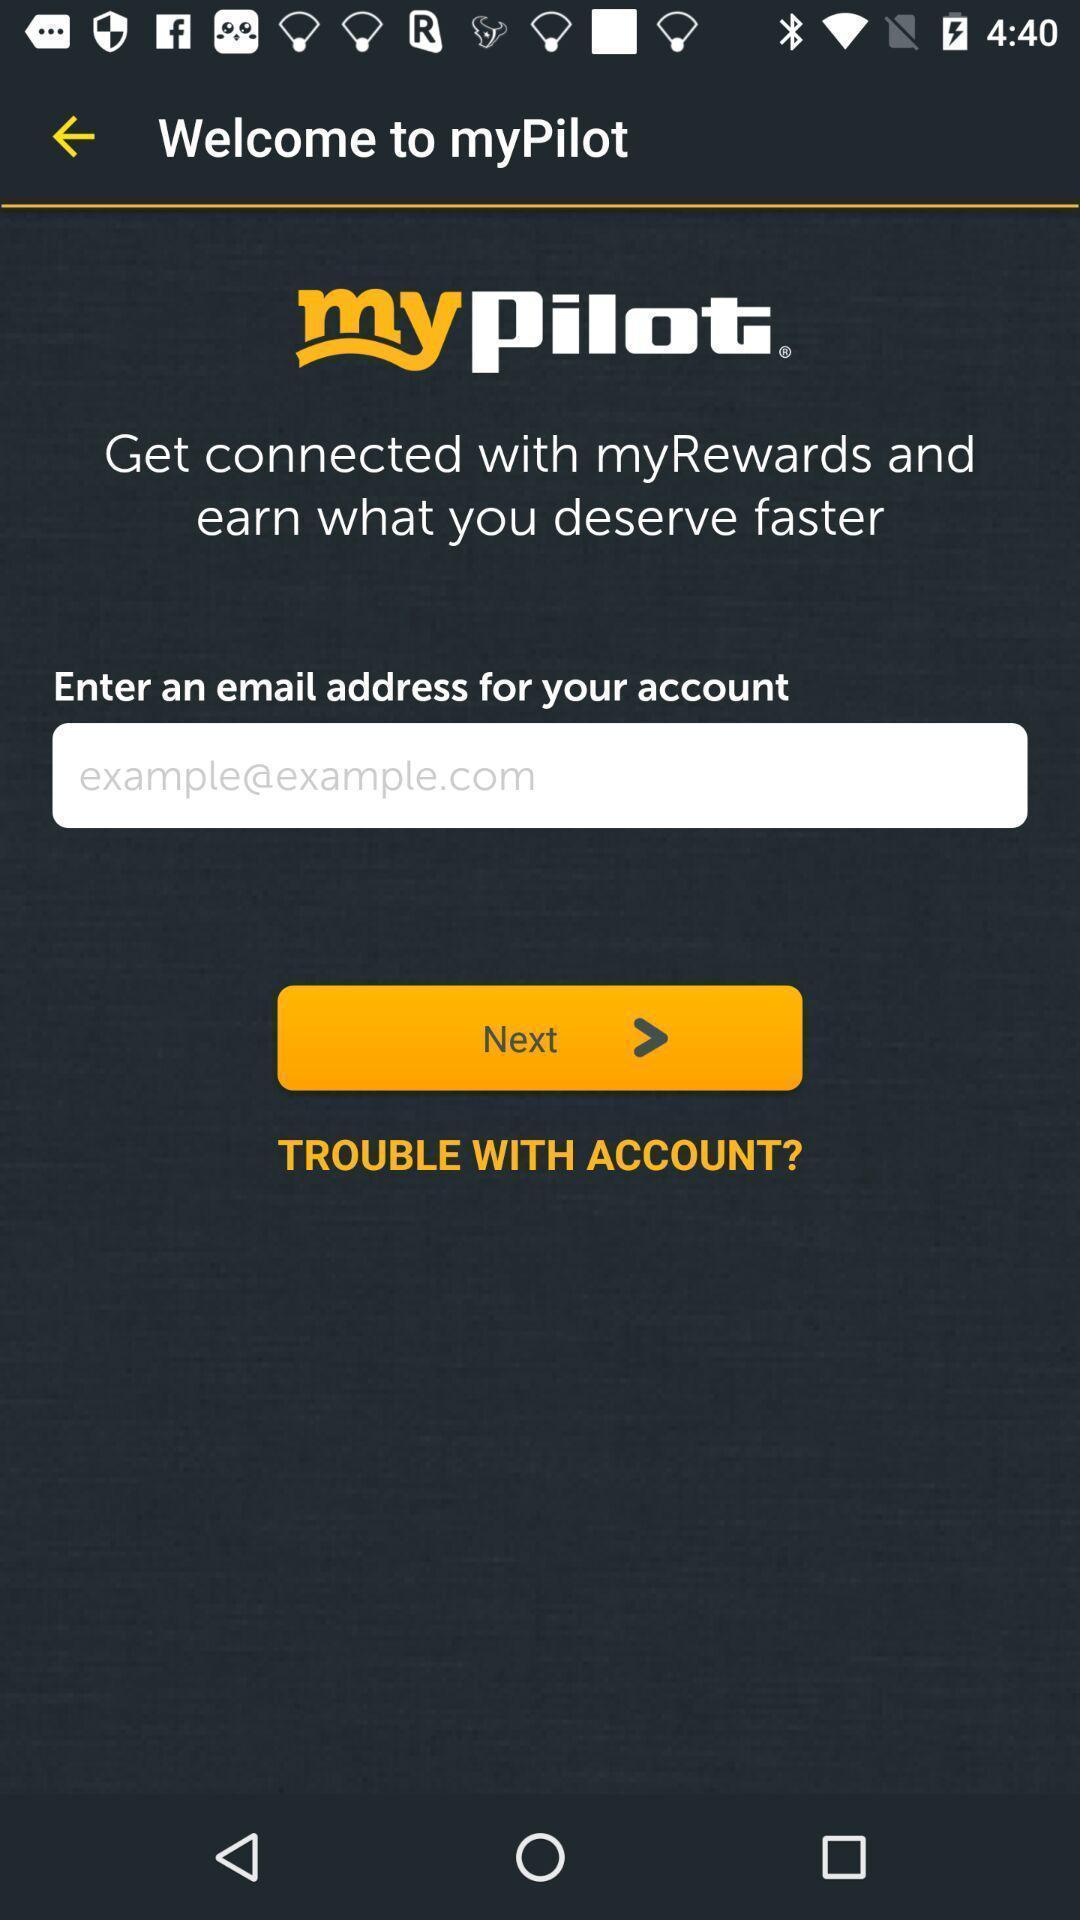Summarize the main components in this picture. Welcome page. 